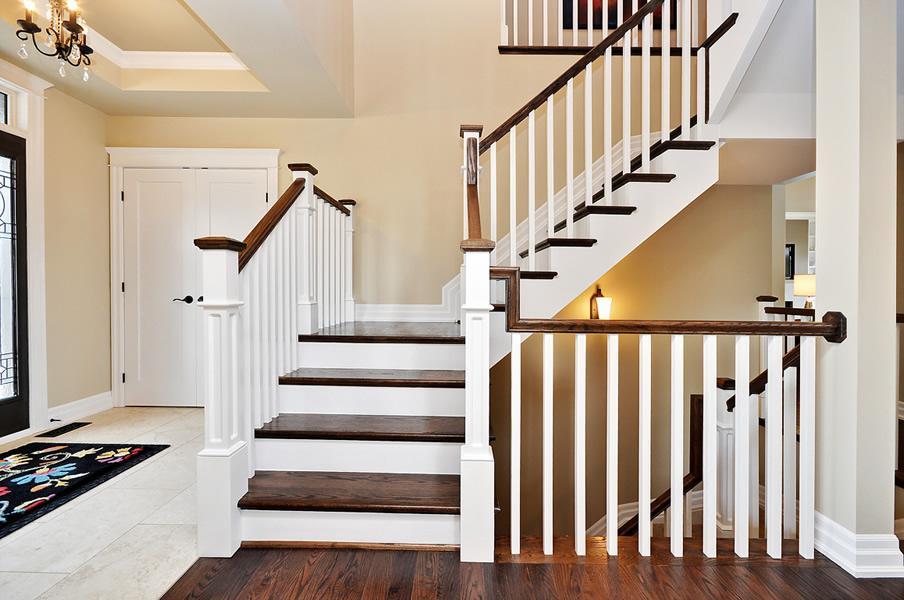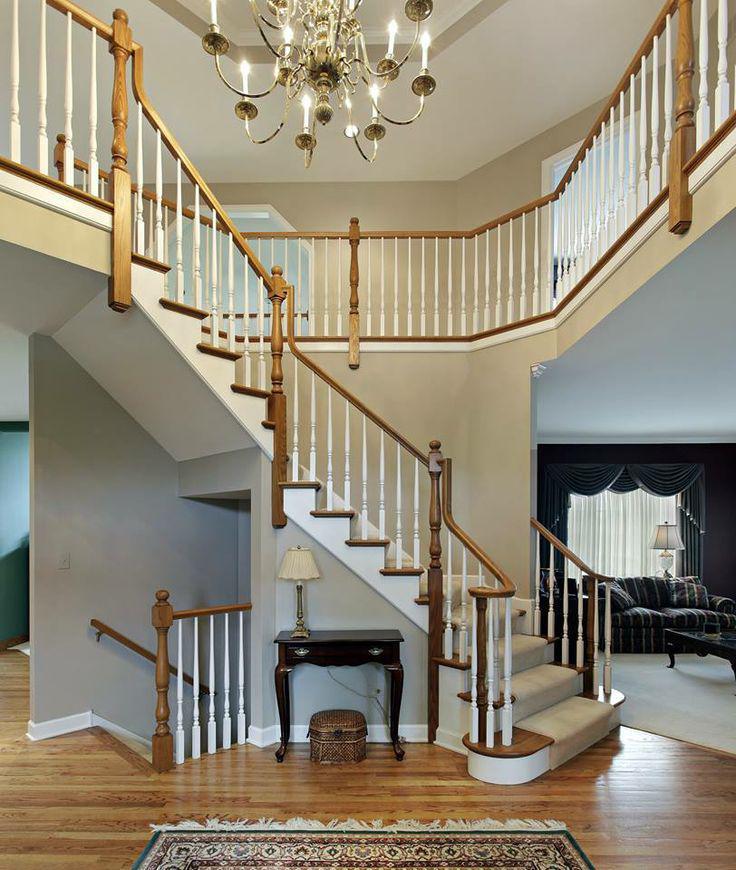The first image is the image on the left, the second image is the image on the right. Considering the images on both sides, is "In at least one image there are brown railed stair that curve as they come down to the floor." valid? Answer yes or no. No. The first image is the image on the left, the second image is the image on the right. Considering the images on both sides, is "The left image features a curving staircase with a wooden handrail and vertical wrought iron bars with a dimensional decorative element." valid? Answer yes or no. No. 